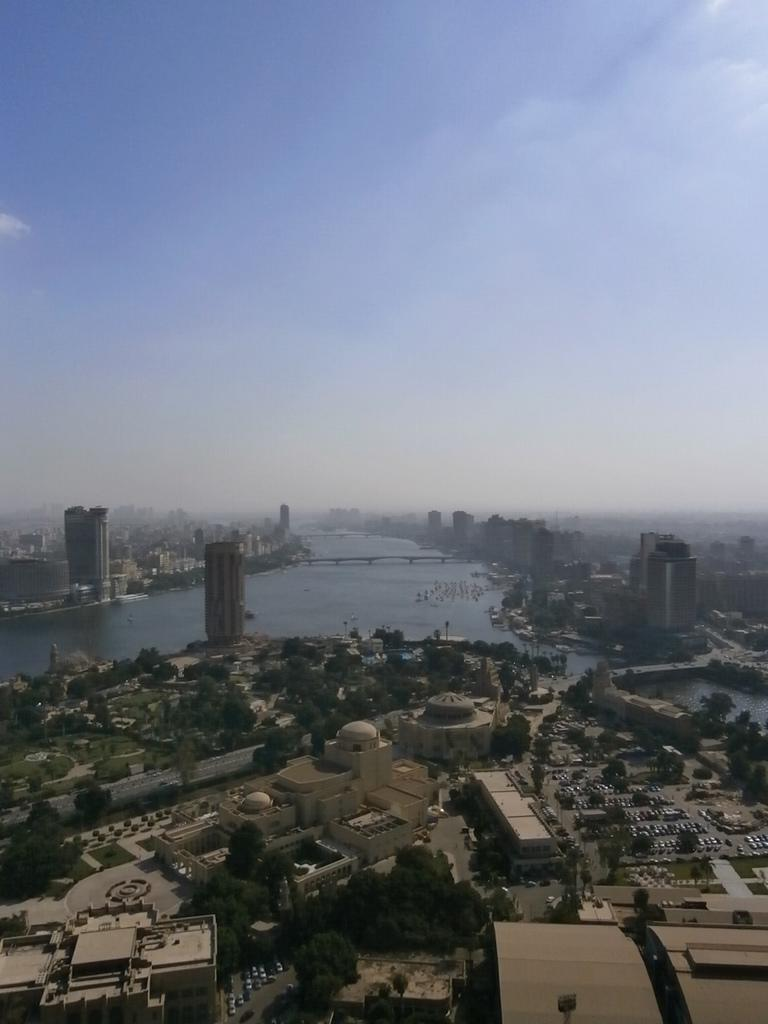What type of structures can be seen in the image? There are buildings in the image. What is the primary mode of transportation visible in the image? There are vehicles in the image. What type of infrastructure is present in the image? There are poles and a bridge in the image. What type of natural elements can be seen in the image? There are trees and water visible in the image. What part of the natural environment is visible in the image? The sky is visible in the image. Can you tell me how many hospitals are visible in the image? There is no hospital present in the image. What level of memory does the image evoke? The image does not evoke a specific level of memory; it is a visual representation of the scene described in the facts. 